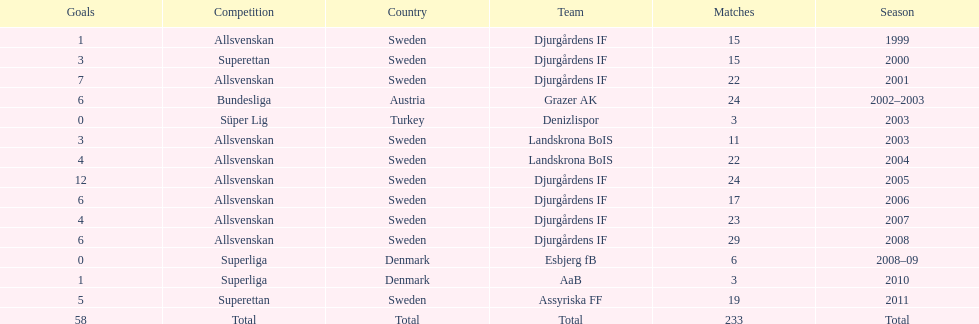How many teams had above 20 matches in the season? 6. 